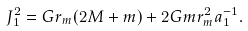Convert formula to latex. <formula><loc_0><loc_0><loc_500><loc_500>J ^ { 2 } _ { 1 } = G r _ { m } ( 2 M + m ) + 2 G m r _ { m } ^ { 2 } a _ { 1 } ^ { - 1 } .</formula> 